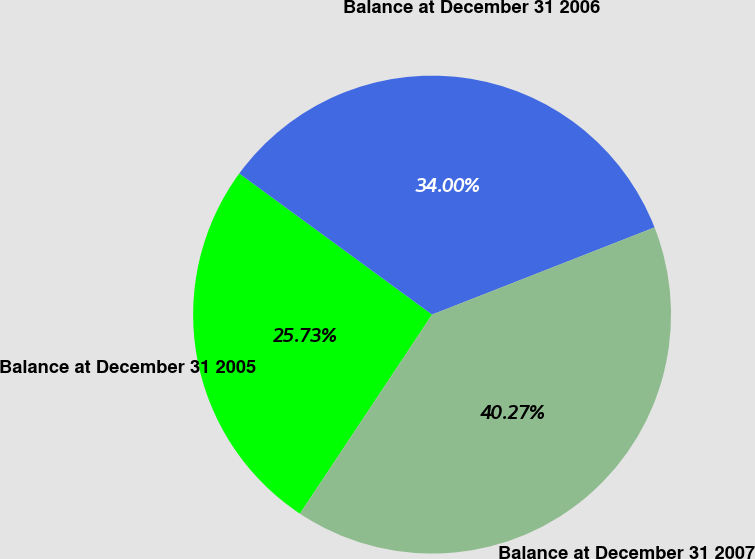Convert chart to OTSL. <chart><loc_0><loc_0><loc_500><loc_500><pie_chart><fcel>Balance at December 31 2005<fcel>Balance at December 31 2006<fcel>Balance at December 31 2007<nl><fcel>25.73%<fcel>34.0%<fcel>40.27%<nl></chart> 